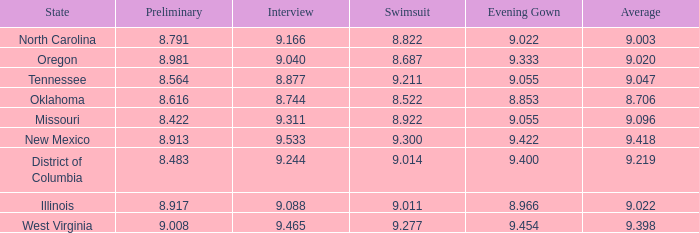Name the preliminary for north carolina 8.791. 